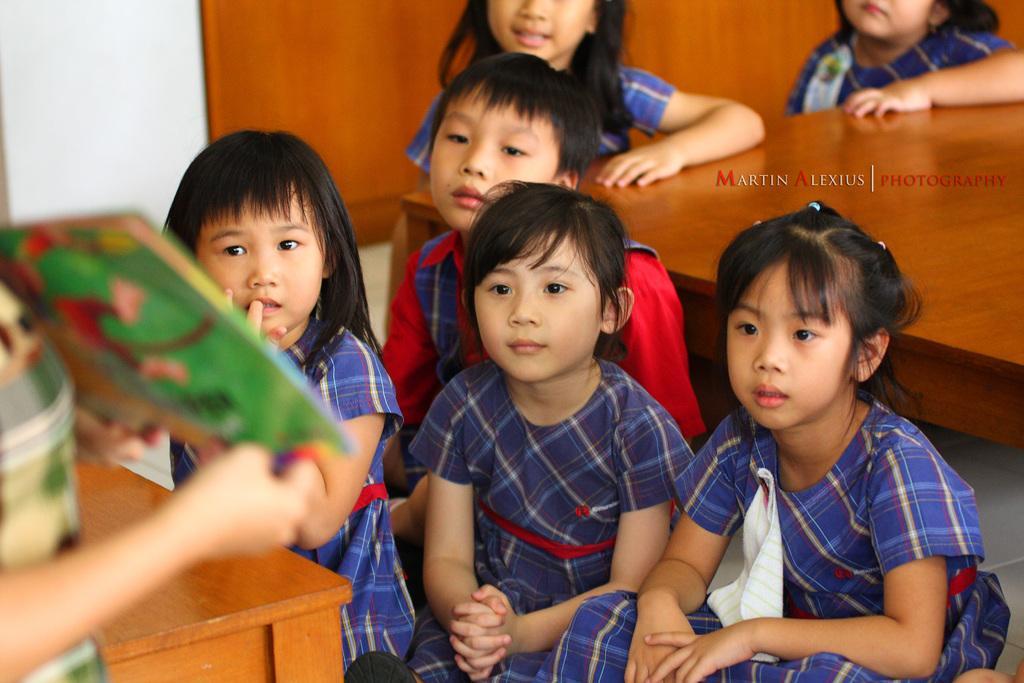How would you summarize this image in a sentence or two? In this picture we can see a group of kids sitting on the path and a person is holding an object. Behind the kids there is a wooden table and a wall. 